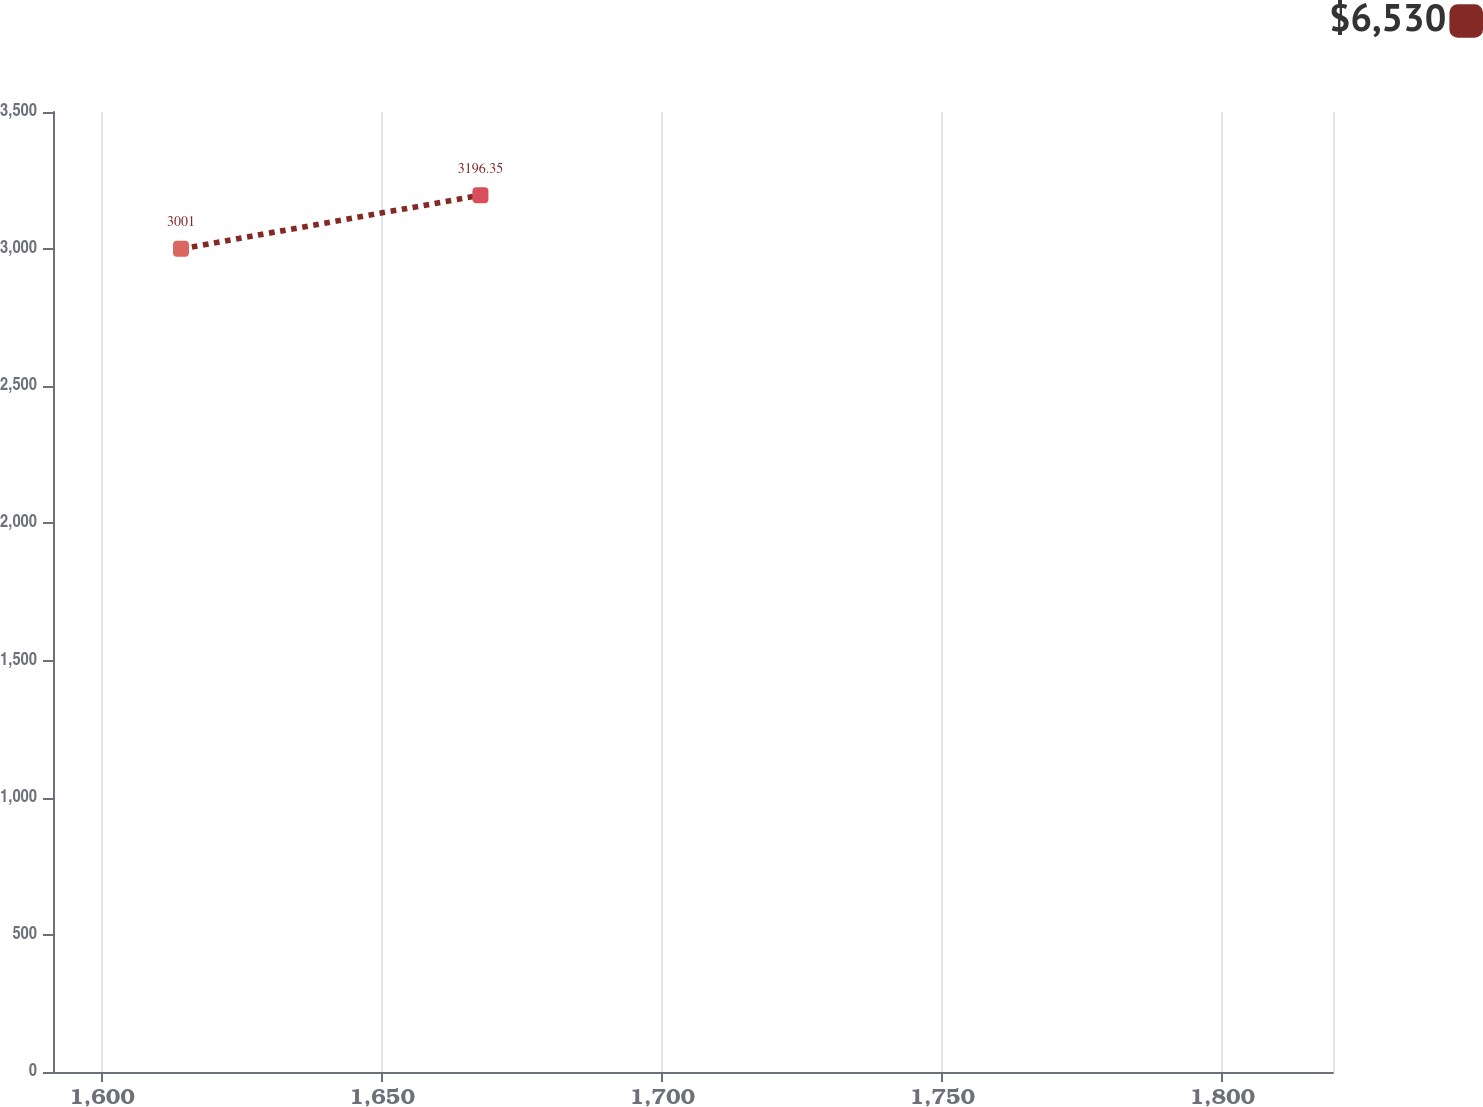<chart> <loc_0><loc_0><loc_500><loc_500><line_chart><ecel><fcel>$6,530<nl><fcel>1614.09<fcel>3001<nl><fcel>1667.55<fcel>3196.35<nl><fcel>1842.62<fcel>1173.42<nl></chart> 